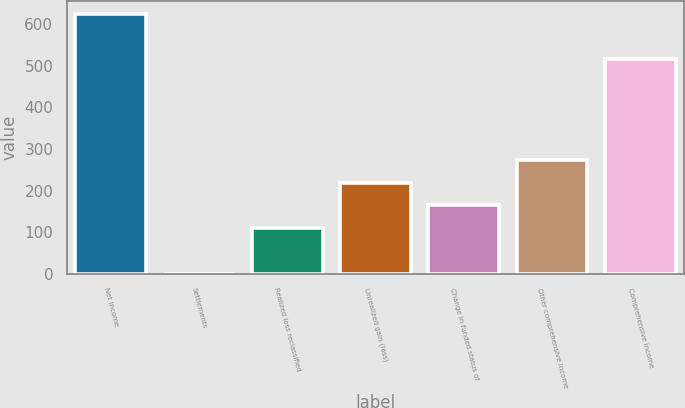Convert chart to OTSL. <chart><loc_0><loc_0><loc_500><loc_500><bar_chart><fcel>Net income<fcel>Settlements<fcel>Realized loss reclassified<fcel>Unrealized gain (loss)<fcel>Change in funded status of<fcel>Other comprehensive income<fcel>Comprehensive income<nl><fcel>625.22<fcel>0.3<fcel>109.82<fcel>219.34<fcel>164.58<fcel>274.1<fcel>515.7<nl></chart> 